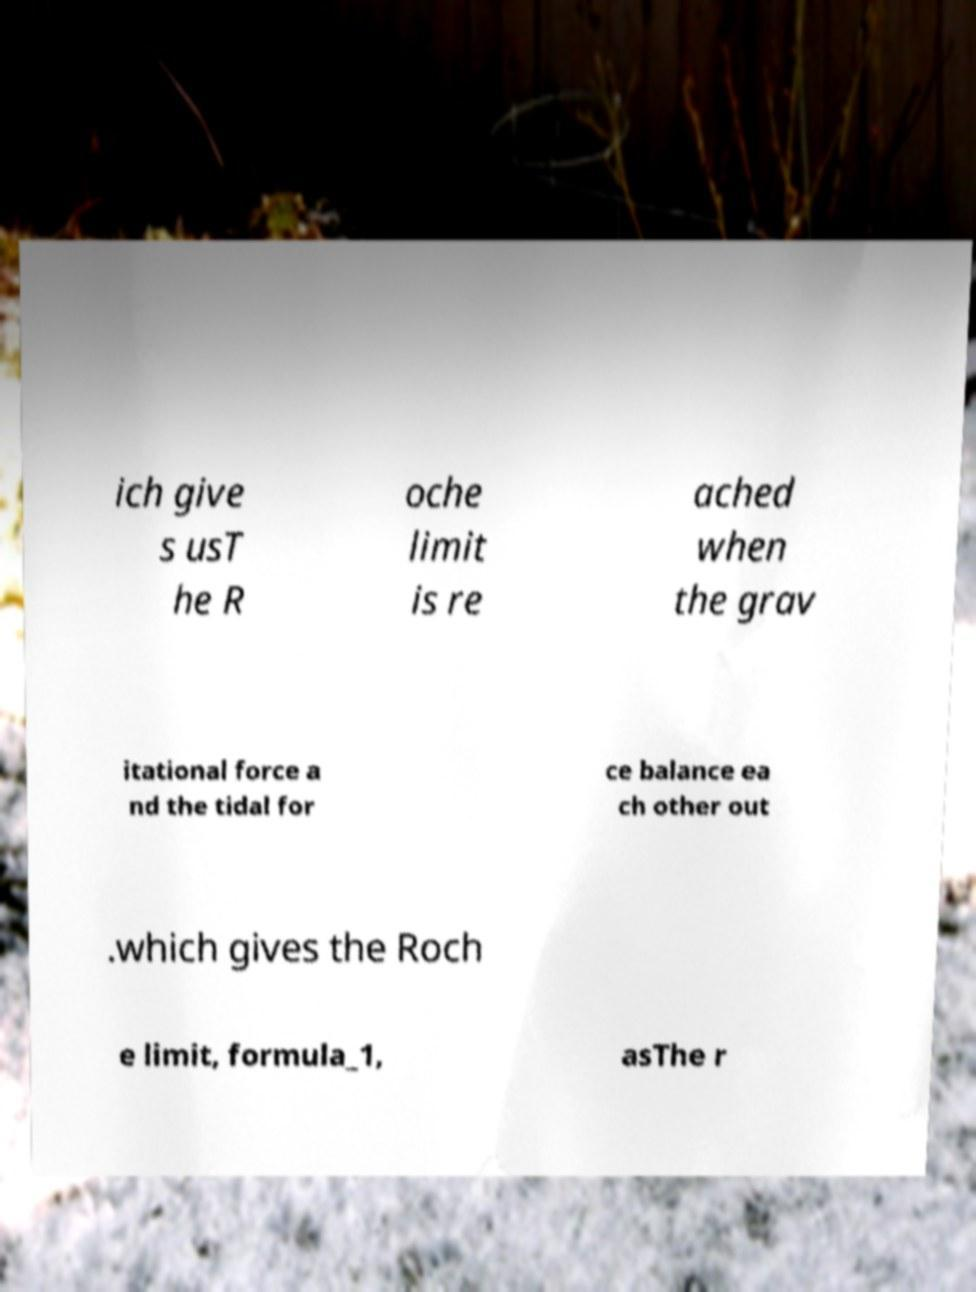Can you read and provide the text displayed in the image?This photo seems to have some interesting text. Can you extract and type it out for me? ich give s usT he R oche limit is re ached when the grav itational force a nd the tidal for ce balance ea ch other out .which gives the Roch e limit, formula_1, asThe r 